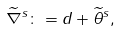<formula> <loc_0><loc_0><loc_500><loc_500>\widetilde { \nabla } ^ { s } \colon = d + \widetilde { \theta } ^ { s } ,</formula> 